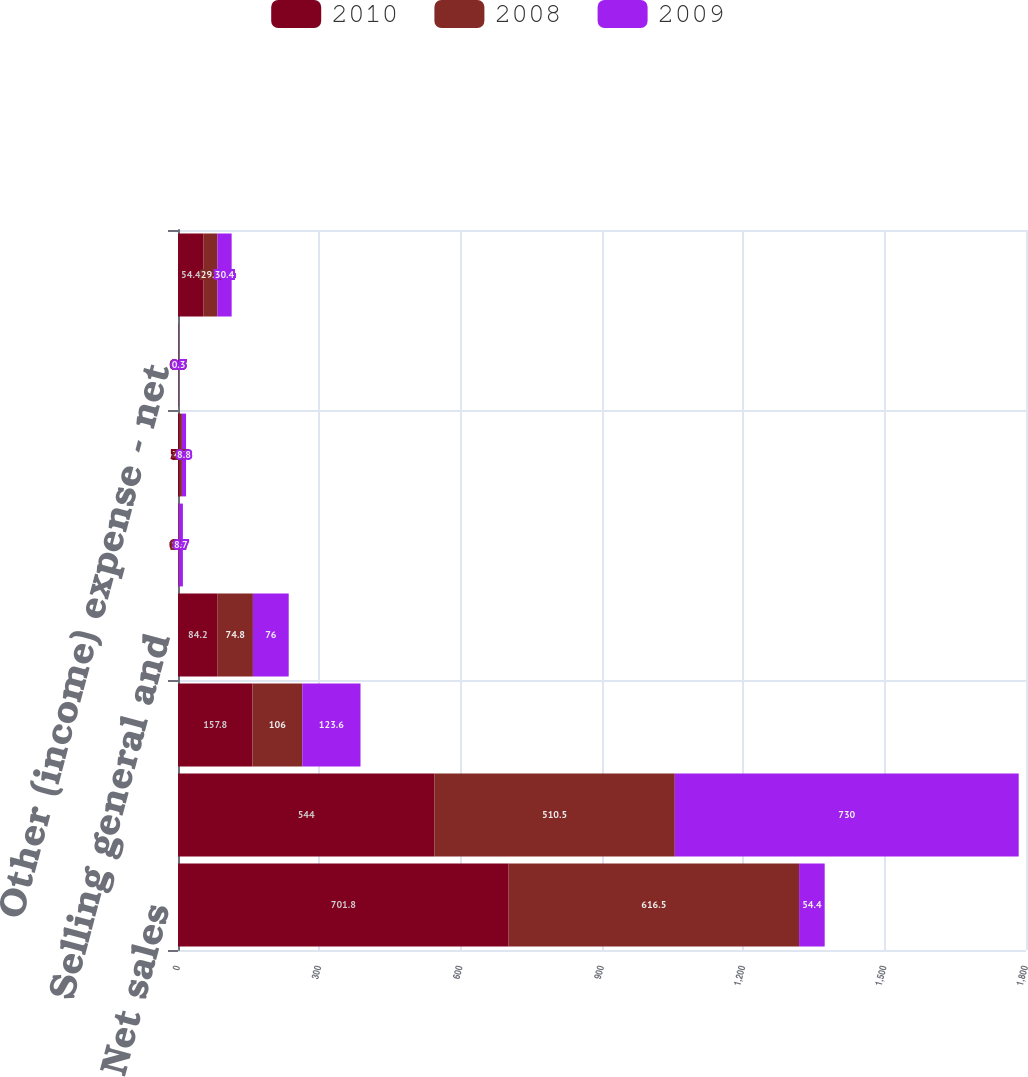<chart> <loc_0><loc_0><loc_500><loc_500><stacked_bar_chart><ecel><fcel>Net sales<fcel>Cost of products sold<fcel>Gross profit<fcel>Selling general and<fcel>Restructuring and other<fcel>Interest expense<fcel>Other (income) expense - net<fcel>Net earnings<nl><fcel>2010<fcel>701.8<fcel>544<fcel>157.8<fcel>84.2<fcel>0.1<fcel>3.6<fcel>0.7<fcel>54.4<nl><fcel>2008<fcel>616.5<fcel>510.5<fcel>106<fcel>74.8<fcel>1.6<fcel>4.7<fcel>0.3<fcel>29.1<nl><fcel>2009<fcel>54.4<fcel>730<fcel>123.6<fcel>76<fcel>8.7<fcel>8.8<fcel>0.3<fcel>30.4<nl></chart> 